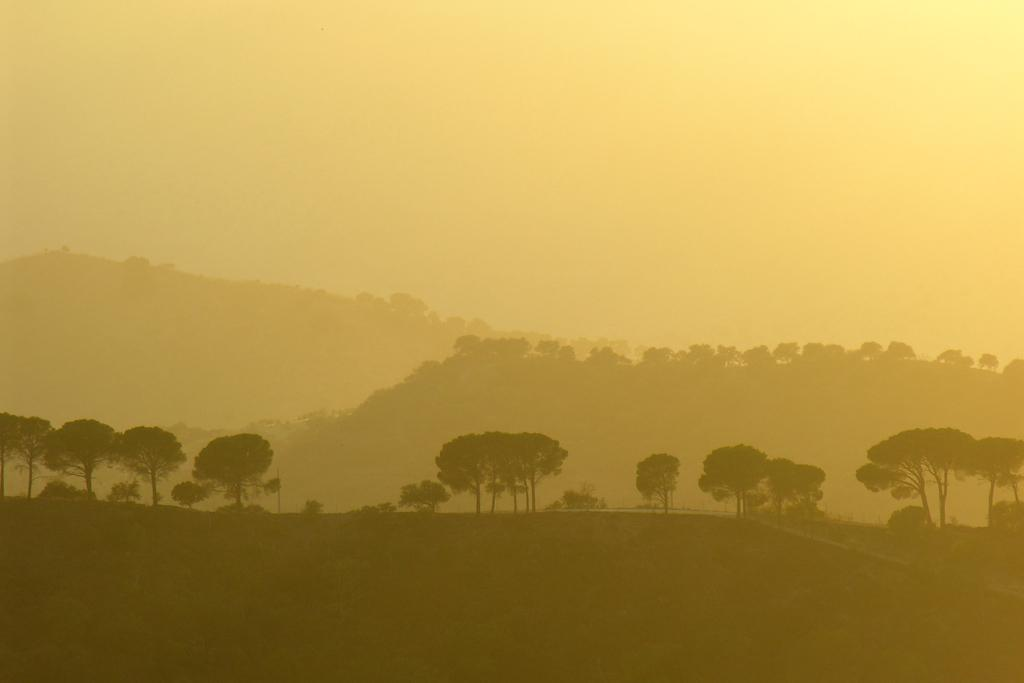What type of vegetation can be seen in the image? There are trees in the image. What geographical features are present in the image? There are hills in the image. What is visible in the background of the image? The sky is visible in the image. Can you tell me how many copies of the lake are present in the image? There is no lake present in the image. What type of can is visible in the image? There is no can present in the image. 